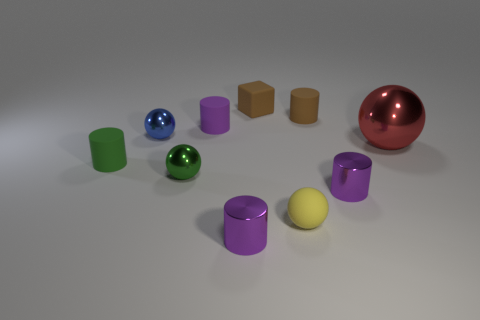Is there anything else that has the same shape as the purple matte thing?
Provide a short and direct response. Yes. What is the color of the cylinder that is in front of the small purple metal thing right of the yellow matte sphere that is in front of the brown rubber block?
Provide a succinct answer. Purple. Is the number of small purple shiny things behind the brown cylinder less than the number of big metallic things that are to the left of the blue metallic sphere?
Provide a short and direct response. No. Is the shape of the small green matte thing the same as the small yellow matte object?
Give a very brief answer. No. How many purple cylinders have the same size as the brown cylinder?
Give a very brief answer. 3. Is the number of rubber cylinders that are in front of the green sphere less than the number of brown matte objects?
Your response must be concise. Yes. There is a matte ball that is in front of the tiny purple object that is behind the small green matte cylinder; what is its size?
Make the answer very short. Small. What number of things are either purple rubber objects or tiny brown matte cubes?
Your answer should be very brief. 2. Are there any tiny matte cubes of the same color as the big ball?
Ensure brevity in your answer.  No. Is the number of small yellow matte balls less than the number of brown things?
Keep it short and to the point. Yes. 